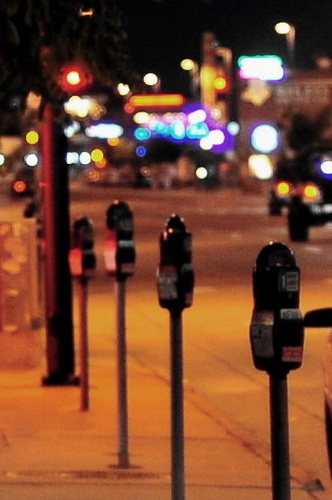Describe the objects in this image and their specific colors. I can see parking meter in black, maroon, and brown tones, car in black, gray, maroon, and white tones, parking meter in black, maroon, gray, and brown tones, parking meter in black, maroon, brown, and salmon tones, and parking meter in black, maroon, red, and brown tones in this image. 